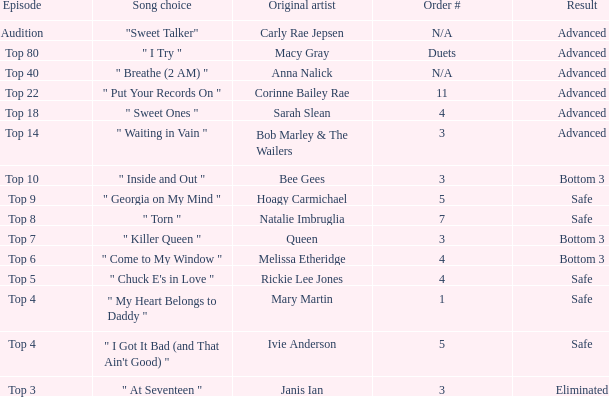Which song was originally rendered by rickie lee jones? " Chuck E's in Love ". 